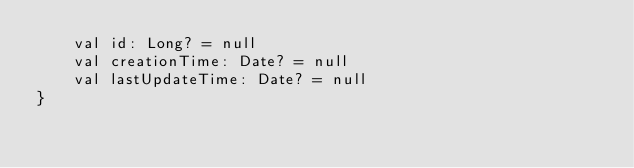Convert code to text. <code><loc_0><loc_0><loc_500><loc_500><_Kotlin_>    val id: Long? = null
    val creationTime: Date? = null
    val lastUpdateTime: Date? = null
}</code> 